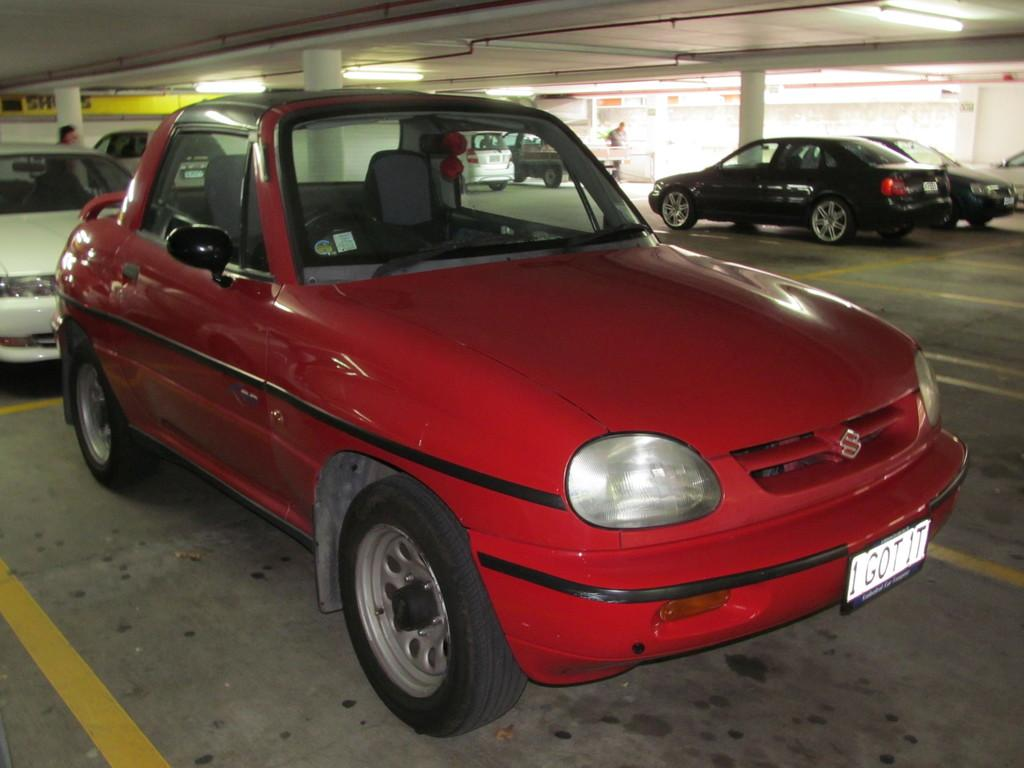What is the main subject in the foreground of the image? There is a red car in the foreground of the image. Can you describe the other vehicles in the image? There are other cars on the right side of the image. What type of discussion is taking place between the judge and the view in the image? There is no judge or view present in the image; it only features a red car and other cars. 